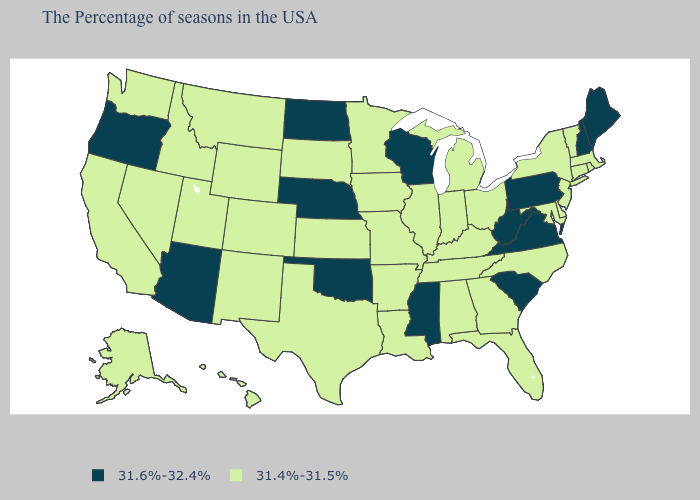What is the highest value in states that border Louisiana?
Keep it brief. 31.6%-32.4%. Which states have the lowest value in the South?
Short answer required. Delaware, Maryland, North Carolina, Florida, Georgia, Kentucky, Alabama, Tennessee, Louisiana, Arkansas, Texas. What is the value of Michigan?
Concise answer only. 31.4%-31.5%. Which states have the lowest value in the USA?
Quick response, please. Massachusetts, Rhode Island, Vermont, Connecticut, New York, New Jersey, Delaware, Maryland, North Carolina, Ohio, Florida, Georgia, Michigan, Kentucky, Indiana, Alabama, Tennessee, Illinois, Louisiana, Missouri, Arkansas, Minnesota, Iowa, Kansas, Texas, South Dakota, Wyoming, Colorado, New Mexico, Utah, Montana, Idaho, Nevada, California, Washington, Alaska, Hawaii. What is the value of Pennsylvania?
Keep it brief. 31.6%-32.4%. What is the highest value in states that border Utah?
Give a very brief answer. 31.6%-32.4%. Name the states that have a value in the range 31.6%-32.4%?
Give a very brief answer. Maine, New Hampshire, Pennsylvania, Virginia, South Carolina, West Virginia, Wisconsin, Mississippi, Nebraska, Oklahoma, North Dakota, Arizona, Oregon. What is the highest value in states that border New Hampshire?
Concise answer only. 31.6%-32.4%. Which states have the highest value in the USA?
Short answer required. Maine, New Hampshire, Pennsylvania, Virginia, South Carolina, West Virginia, Wisconsin, Mississippi, Nebraska, Oklahoma, North Dakota, Arizona, Oregon. Does Pennsylvania have the highest value in the USA?
Short answer required. Yes. Which states hav the highest value in the MidWest?
Concise answer only. Wisconsin, Nebraska, North Dakota. Does North Carolina have the same value as Wisconsin?
Be succinct. No. Does North Carolina have the highest value in the USA?
Write a very short answer. No. Name the states that have a value in the range 31.4%-31.5%?
Keep it brief. Massachusetts, Rhode Island, Vermont, Connecticut, New York, New Jersey, Delaware, Maryland, North Carolina, Ohio, Florida, Georgia, Michigan, Kentucky, Indiana, Alabama, Tennessee, Illinois, Louisiana, Missouri, Arkansas, Minnesota, Iowa, Kansas, Texas, South Dakota, Wyoming, Colorado, New Mexico, Utah, Montana, Idaho, Nevada, California, Washington, Alaska, Hawaii. Name the states that have a value in the range 31.4%-31.5%?
Keep it brief. Massachusetts, Rhode Island, Vermont, Connecticut, New York, New Jersey, Delaware, Maryland, North Carolina, Ohio, Florida, Georgia, Michigan, Kentucky, Indiana, Alabama, Tennessee, Illinois, Louisiana, Missouri, Arkansas, Minnesota, Iowa, Kansas, Texas, South Dakota, Wyoming, Colorado, New Mexico, Utah, Montana, Idaho, Nevada, California, Washington, Alaska, Hawaii. 